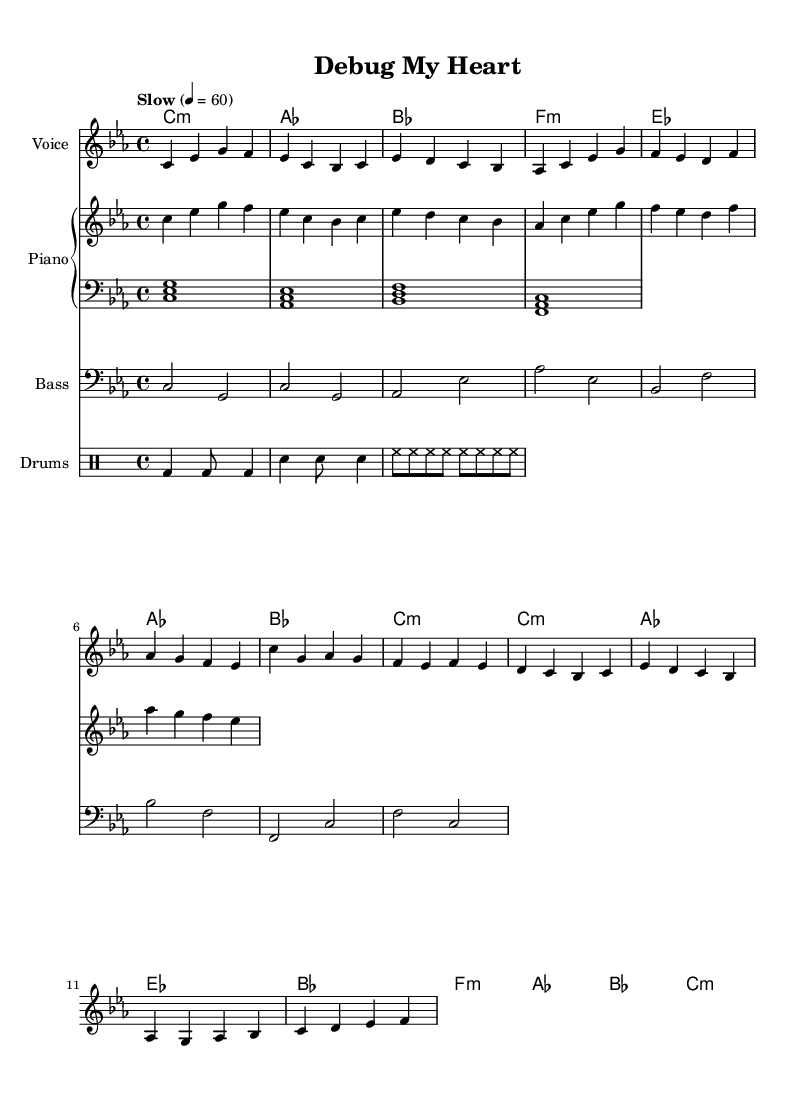What is the key signature of this music? The key signature indicates that the music is in C minor, which has three flats (B, E, A). This is determined by observing the key signature at the beginning of the staff.
Answer: C minor What is the time signature used in the piece? The time signature, located at the beginning of the piece, shows a 4/4, meaning there are four beats in each measure and the quarter note gets one beat.
Answer: 4/4 What is the tempo marking of this piece? The tempo marking is given in terms of beats per minute, here stated as "Slow" with a metronome marking of quarter note equals 60. This indicates a slow pace for the piece.
Answer: Slow How many measures are there in the melody? By counting the groupings of notes and each bar line in the melody part, we can identify there are a total of 8 measures present.
Answer: 8 measures What is the predominant genre of this music? The style of the music, along with its lyrical themes of overcoming challenges conveyed through soulful melodies, suggests that the genre is Rhythm and Blues.
Answer: Rhythm and Blues What are the primary chords used in the piece? Analyzing the chord progression reveals the usage of C minor, A flat major, B flat major, F minor, and E flat major. These chords are expressed in the chord section of the sheet music.
Answer: C minor, A flat major, B flat major, F minor, E flat major How do the drums contribute to the overall feel of the music? The drum pattern includes a simple bass and snare structure with a consistent hi-hat rhythm, providing a steady groove that enhances the emotional weight of the soulful ballad feel.
Answer: Steady groove 